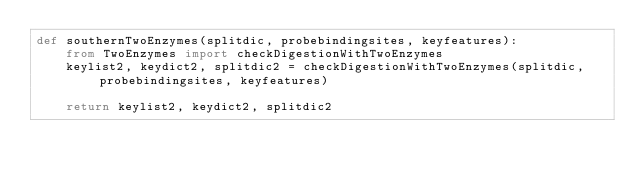<code> <loc_0><loc_0><loc_500><loc_500><_Python_>def southernTwoEnzymes(splitdic, probebindingsites, keyfeatures):
    from TwoEnzymes import checkDigestionWithTwoEnzymes
    keylist2, keydict2, splitdic2 = checkDigestionWithTwoEnzymes(splitdic, probebindingsites, keyfeatures)

    return keylist2, keydict2, splitdic2
</code> 